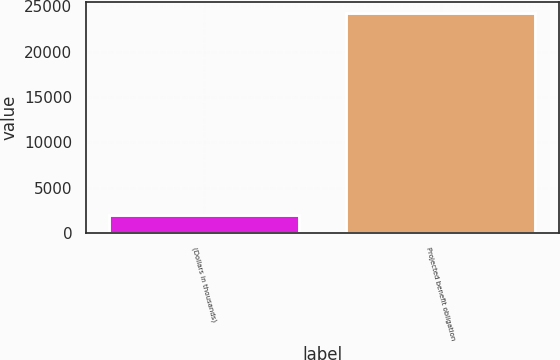Convert chart to OTSL. <chart><loc_0><loc_0><loc_500><loc_500><bar_chart><fcel>(Dollars in thousands)<fcel>Projected benefit obligation<nl><fcel>2006<fcel>24299<nl></chart> 